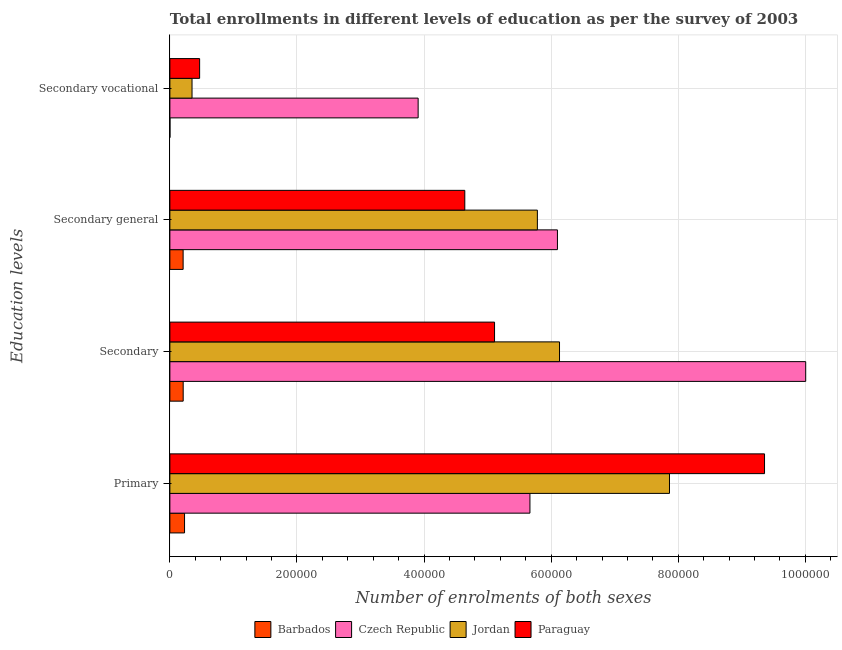Are the number of bars per tick equal to the number of legend labels?
Keep it short and to the point. Yes. Are the number of bars on each tick of the Y-axis equal?
Make the answer very short. Yes. How many bars are there on the 1st tick from the top?
Your answer should be very brief. 4. How many bars are there on the 4th tick from the bottom?
Keep it short and to the point. 4. What is the label of the 4th group of bars from the top?
Your answer should be very brief. Primary. What is the number of enrolments in secondary education in Czech Republic?
Offer a very short reply. 1.00e+06. Across all countries, what is the maximum number of enrolments in secondary education?
Make the answer very short. 1.00e+06. Across all countries, what is the minimum number of enrolments in secondary general education?
Ensure brevity in your answer.  2.08e+04. In which country was the number of enrolments in secondary vocational education maximum?
Offer a very short reply. Czech Republic. In which country was the number of enrolments in secondary vocational education minimum?
Ensure brevity in your answer.  Barbados. What is the total number of enrolments in primary education in the graph?
Provide a succinct answer. 2.31e+06. What is the difference between the number of enrolments in secondary vocational education in Czech Republic and that in Jordan?
Your answer should be compact. 3.56e+05. What is the difference between the number of enrolments in secondary vocational education in Czech Republic and the number of enrolments in primary education in Barbados?
Offer a terse response. 3.68e+05. What is the average number of enrolments in primary education per country?
Offer a terse response. 5.78e+05. What is the difference between the number of enrolments in secondary vocational education and number of enrolments in secondary general education in Jordan?
Offer a very short reply. -5.43e+05. In how many countries, is the number of enrolments in secondary general education greater than 1000000 ?
Ensure brevity in your answer.  0. What is the ratio of the number of enrolments in secondary vocational education in Paraguay to that in Jordan?
Provide a succinct answer. 1.34. Is the number of enrolments in secondary education in Czech Republic less than that in Paraguay?
Offer a very short reply. No. What is the difference between the highest and the second highest number of enrolments in primary education?
Offer a very short reply. 1.50e+05. What is the difference between the highest and the lowest number of enrolments in primary education?
Your answer should be very brief. 9.13e+05. Is the sum of the number of enrolments in secondary vocational education in Czech Republic and Jordan greater than the maximum number of enrolments in primary education across all countries?
Ensure brevity in your answer.  No. What does the 1st bar from the top in Secondary represents?
Provide a short and direct response. Paraguay. What does the 3rd bar from the bottom in Primary represents?
Provide a succinct answer. Jordan. Is it the case that in every country, the sum of the number of enrolments in primary education and number of enrolments in secondary education is greater than the number of enrolments in secondary general education?
Give a very brief answer. Yes. Are all the bars in the graph horizontal?
Make the answer very short. Yes. What is the difference between two consecutive major ticks on the X-axis?
Offer a terse response. 2.00e+05. How are the legend labels stacked?
Give a very brief answer. Horizontal. What is the title of the graph?
Provide a succinct answer. Total enrollments in different levels of education as per the survey of 2003. Does "Uruguay" appear as one of the legend labels in the graph?
Offer a terse response. No. What is the label or title of the X-axis?
Offer a very short reply. Number of enrolments of both sexes. What is the label or title of the Y-axis?
Your answer should be compact. Education levels. What is the Number of enrolments of both sexes of Barbados in Primary?
Offer a very short reply. 2.31e+04. What is the Number of enrolments of both sexes in Czech Republic in Primary?
Offer a terse response. 5.67e+05. What is the Number of enrolments of both sexes of Jordan in Primary?
Ensure brevity in your answer.  7.86e+05. What is the Number of enrolments of both sexes in Paraguay in Primary?
Your answer should be compact. 9.36e+05. What is the Number of enrolments of both sexes in Barbados in Secondary?
Your answer should be compact. 2.09e+04. What is the Number of enrolments of both sexes in Czech Republic in Secondary?
Your answer should be very brief. 1.00e+06. What is the Number of enrolments of both sexes of Jordan in Secondary?
Offer a very short reply. 6.13e+05. What is the Number of enrolments of both sexes in Paraguay in Secondary?
Ensure brevity in your answer.  5.11e+05. What is the Number of enrolments of both sexes in Barbados in Secondary general?
Provide a succinct answer. 2.08e+04. What is the Number of enrolments of both sexes of Czech Republic in Secondary general?
Make the answer very short. 6.10e+05. What is the Number of enrolments of both sexes of Jordan in Secondary general?
Give a very brief answer. 5.78e+05. What is the Number of enrolments of both sexes of Paraguay in Secondary general?
Ensure brevity in your answer.  4.64e+05. What is the Number of enrolments of both sexes in Barbados in Secondary vocational?
Keep it short and to the point. 109. What is the Number of enrolments of both sexes of Czech Republic in Secondary vocational?
Offer a very short reply. 3.91e+05. What is the Number of enrolments of both sexes in Jordan in Secondary vocational?
Ensure brevity in your answer.  3.49e+04. What is the Number of enrolments of both sexes of Paraguay in Secondary vocational?
Provide a succinct answer. 4.68e+04. Across all Education levels, what is the maximum Number of enrolments of both sexes of Barbados?
Provide a succinct answer. 2.31e+04. Across all Education levels, what is the maximum Number of enrolments of both sexes of Czech Republic?
Your answer should be very brief. 1.00e+06. Across all Education levels, what is the maximum Number of enrolments of both sexes of Jordan?
Ensure brevity in your answer.  7.86e+05. Across all Education levels, what is the maximum Number of enrolments of both sexes in Paraguay?
Keep it short and to the point. 9.36e+05. Across all Education levels, what is the minimum Number of enrolments of both sexes of Barbados?
Your answer should be compact. 109. Across all Education levels, what is the minimum Number of enrolments of both sexes of Czech Republic?
Your response must be concise. 3.91e+05. Across all Education levels, what is the minimum Number of enrolments of both sexes of Jordan?
Give a very brief answer. 3.49e+04. Across all Education levels, what is the minimum Number of enrolments of both sexes of Paraguay?
Offer a terse response. 4.68e+04. What is the total Number of enrolments of both sexes of Barbados in the graph?
Provide a succinct answer. 6.50e+04. What is the total Number of enrolments of both sexes in Czech Republic in the graph?
Offer a terse response. 2.57e+06. What is the total Number of enrolments of both sexes of Jordan in the graph?
Provide a short and direct response. 2.01e+06. What is the total Number of enrolments of both sexes in Paraguay in the graph?
Make the answer very short. 1.96e+06. What is the difference between the Number of enrolments of both sexes of Barbados in Primary and that in Secondary?
Offer a terse response. 2127. What is the difference between the Number of enrolments of both sexes of Czech Republic in Primary and that in Secondary?
Keep it short and to the point. -4.34e+05. What is the difference between the Number of enrolments of both sexes of Jordan in Primary and that in Secondary?
Offer a terse response. 1.73e+05. What is the difference between the Number of enrolments of both sexes of Paraguay in Primary and that in Secondary?
Your answer should be very brief. 4.25e+05. What is the difference between the Number of enrolments of both sexes of Barbados in Primary and that in Secondary general?
Keep it short and to the point. 2236. What is the difference between the Number of enrolments of both sexes of Czech Republic in Primary and that in Secondary general?
Give a very brief answer. -4.33e+04. What is the difference between the Number of enrolments of both sexes in Jordan in Primary and that in Secondary general?
Give a very brief answer. 2.08e+05. What is the difference between the Number of enrolments of both sexes of Paraguay in Primary and that in Secondary general?
Your answer should be compact. 4.72e+05. What is the difference between the Number of enrolments of both sexes in Barbados in Primary and that in Secondary vocational?
Ensure brevity in your answer.  2.30e+04. What is the difference between the Number of enrolments of both sexes in Czech Republic in Primary and that in Secondary vocational?
Offer a very short reply. 1.76e+05. What is the difference between the Number of enrolments of both sexes in Jordan in Primary and that in Secondary vocational?
Ensure brevity in your answer.  7.51e+05. What is the difference between the Number of enrolments of both sexes in Paraguay in Primary and that in Secondary vocational?
Give a very brief answer. 8.89e+05. What is the difference between the Number of enrolments of both sexes of Barbados in Secondary and that in Secondary general?
Offer a terse response. 109. What is the difference between the Number of enrolments of both sexes of Czech Republic in Secondary and that in Secondary general?
Offer a terse response. 3.91e+05. What is the difference between the Number of enrolments of both sexes of Jordan in Secondary and that in Secondary general?
Provide a short and direct response. 3.49e+04. What is the difference between the Number of enrolments of both sexes in Paraguay in Secondary and that in Secondary general?
Ensure brevity in your answer.  4.68e+04. What is the difference between the Number of enrolments of both sexes of Barbados in Secondary and that in Secondary vocational?
Ensure brevity in your answer.  2.08e+04. What is the difference between the Number of enrolments of both sexes in Czech Republic in Secondary and that in Secondary vocational?
Give a very brief answer. 6.10e+05. What is the difference between the Number of enrolments of both sexes of Jordan in Secondary and that in Secondary vocational?
Your response must be concise. 5.78e+05. What is the difference between the Number of enrolments of both sexes of Paraguay in Secondary and that in Secondary vocational?
Give a very brief answer. 4.64e+05. What is the difference between the Number of enrolments of both sexes of Barbados in Secondary general and that in Secondary vocational?
Offer a very short reply. 2.07e+04. What is the difference between the Number of enrolments of both sexes of Czech Republic in Secondary general and that in Secondary vocational?
Make the answer very short. 2.19e+05. What is the difference between the Number of enrolments of both sexes of Jordan in Secondary general and that in Secondary vocational?
Your response must be concise. 5.43e+05. What is the difference between the Number of enrolments of both sexes of Paraguay in Secondary general and that in Secondary vocational?
Offer a very short reply. 4.17e+05. What is the difference between the Number of enrolments of both sexes in Barbados in Primary and the Number of enrolments of both sexes in Czech Republic in Secondary?
Ensure brevity in your answer.  -9.77e+05. What is the difference between the Number of enrolments of both sexes in Barbados in Primary and the Number of enrolments of both sexes in Jordan in Secondary?
Ensure brevity in your answer.  -5.90e+05. What is the difference between the Number of enrolments of both sexes in Barbados in Primary and the Number of enrolments of both sexes in Paraguay in Secondary?
Your response must be concise. -4.88e+05. What is the difference between the Number of enrolments of both sexes of Czech Republic in Primary and the Number of enrolments of both sexes of Jordan in Secondary?
Your answer should be compact. -4.65e+04. What is the difference between the Number of enrolments of both sexes in Czech Republic in Primary and the Number of enrolments of both sexes in Paraguay in Secondary?
Ensure brevity in your answer.  5.57e+04. What is the difference between the Number of enrolments of both sexes in Jordan in Primary and the Number of enrolments of both sexes in Paraguay in Secondary?
Ensure brevity in your answer.  2.75e+05. What is the difference between the Number of enrolments of both sexes of Barbados in Primary and the Number of enrolments of both sexes of Czech Republic in Secondary general?
Your response must be concise. -5.87e+05. What is the difference between the Number of enrolments of both sexes of Barbados in Primary and the Number of enrolments of both sexes of Jordan in Secondary general?
Provide a succinct answer. -5.55e+05. What is the difference between the Number of enrolments of both sexes of Barbados in Primary and the Number of enrolments of both sexes of Paraguay in Secondary general?
Provide a succinct answer. -4.41e+05. What is the difference between the Number of enrolments of both sexes of Czech Republic in Primary and the Number of enrolments of both sexes of Jordan in Secondary general?
Make the answer very short. -1.17e+04. What is the difference between the Number of enrolments of both sexes in Czech Republic in Primary and the Number of enrolments of both sexes in Paraguay in Secondary general?
Keep it short and to the point. 1.03e+05. What is the difference between the Number of enrolments of both sexes of Jordan in Primary and the Number of enrolments of both sexes of Paraguay in Secondary general?
Make the answer very short. 3.22e+05. What is the difference between the Number of enrolments of both sexes in Barbados in Primary and the Number of enrolments of both sexes in Czech Republic in Secondary vocational?
Your answer should be very brief. -3.68e+05. What is the difference between the Number of enrolments of both sexes of Barbados in Primary and the Number of enrolments of both sexes of Jordan in Secondary vocational?
Offer a very short reply. -1.18e+04. What is the difference between the Number of enrolments of both sexes in Barbados in Primary and the Number of enrolments of both sexes in Paraguay in Secondary vocational?
Your answer should be very brief. -2.37e+04. What is the difference between the Number of enrolments of both sexes of Czech Republic in Primary and the Number of enrolments of both sexes of Jordan in Secondary vocational?
Give a very brief answer. 5.32e+05. What is the difference between the Number of enrolments of both sexes of Czech Republic in Primary and the Number of enrolments of both sexes of Paraguay in Secondary vocational?
Provide a short and direct response. 5.20e+05. What is the difference between the Number of enrolments of both sexes in Jordan in Primary and the Number of enrolments of both sexes in Paraguay in Secondary vocational?
Make the answer very short. 7.39e+05. What is the difference between the Number of enrolments of both sexes of Barbados in Secondary and the Number of enrolments of both sexes of Czech Republic in Secondary general?
Provide a short and direct response. -5.89e+05. What is the difference between the Number of enrolments of both sexes in Barbados in Secondary and the Number of enrolments of both sexes in Jordan in Secondary general?
Offer a very short reply. -5.57e+05. What is the difference between the Number of enrolments of both sexes in Barbados in Secondary and the Number of enrolments of both sexes in Paraguay in Secondary general?
Offer a terse response. -4.43e+05. What is the difference between the Number of enrolments of both sexes of Czech Republic in Secondary and the Number of enrolments of both sexes of Jordan in Secondary general?
Ensure brevity in your answer.  4.22e+05. What is the difference between the Number of enrolments of both sexes in Czech Republic in Secondary and the Number of enrolments of both sexes in Paraguay in Secondary general?
Keep it short and to the point. 5.36e+05. What is the difference between the Number of enrolments of both sexes of Jordan in Secondary and the Number of enrolments of both sexes of Paraguay in Secondary general?
Make the answer very short. 1.49e+05. What is the difference between the Number of enrolments of both sexes of Barbados in Secondary and the Number of enrolments of both sexes of Czech Republic in Secondary vocational?
Your response must be concise. -3.70e+05. What is the difference between the Number of enrolments of both sexes in Barbados in Secondary and the Number of enrolments of both sexes in Jordan in Secondary vocational?
Your response must be concise. -1.39e+04. What is the difference between the Number of enrolments of both sexes of Barbados in Secondary and the Number of enrolments of both sexes of Paraguay in Secondary vocational?
Offer a very short reply. -2.59e+04. What is the difference between the Number of enrolments of both sexes in Czech Republic in Secondary and the Number of enrolments of both sexes in Jordan in Secondary vocational?
Provide a short and direct response. 9.66e+05. What is the difference between the Number of enrolments of both sexes in Czech Republic in Secondary and the Number of enrolments of both sexes in Paraguay in Secondary vocational?
Your answer should be compact. 9.54e+05. What is the difference between the Number of enrolments of both sexes in Jordan in Secondary and the Number of enrolments of both sexes in Paraguay in Secondary vocational?
Offer a terse response. 5.66e+05. What is the difference between the Number of enrolments of both sexes in Barbados in Secondary general and the Number of enrolments of both sexes in Czech Republic in Secondary vocational?
Ensure brevity in your answer.  -3.70e+05. What is the difference between the Number of enrolments of both sexes of Barbados in Secondary general and the Number of enrolments of both sexes of Jordan in Secondary vocational?
Offer a terse response. -1.40e+04. What is the difference between the Number of enrolments of both sexes of Barbados in Secondary general and the Number of enrolments of both sexes of Paraguay in Secondary vocational?
Provide a short and direct response. -2.60e+04. What is the difference between the Number of enrolments of both sexes of Czech Republic in Secondary general and the Number of enrolments of both sexes of Jordan in Secondary vocational?
Make the answer very short. 5.75e+05. What is the difference between the Number of enrolments of both sexes in Czech Republic in Secondary general and the Number of enrolments of both sexes in Paraguay in Secondary vocational?
Your answer should be very brief. 5.63e+05. What is the difference between the Number of enrolments of both sexes in Jordan in Secondary general and the Number of enrolments of both sexes in Paraguay in Secondary vocational?
Make the answer very short. 5.31e+05. What is the average Number of enrolments of both sexes of Barbados per Education levels?
Ensure brevity in your answer.  1.62e+04. What is the average Number of enrolments of both sexes in Czech Republic per Education levels?
Your response must be concise. 6.42e+05. What is the average Number of enrolments of both sexes in Jordan per Education levels?
Your answer should be compact. 5.03e+05. What is the average Number of enrolments of both sexes in Paraguay per Education levels?
Offer a very short reply. 4.89e+05. What is the difference between the Number of enrolments of both sexes in Barbados and Number of enrolments of both sexes in Czech Republic in Primary?
Your answer should be compact. -5.44e+05. What is the difference between the Number of enrolments of both sexes in Barbados and Number of enrolments of both sexes in Jordan in Primary?
Provide a succinct answer. -7.63e+05. What is the difference between the Number of enrolments of both sexes in Barbados and Number of enrolments of both sexes in Paraguay in Primary?
Provide a succinct answer. -9.13e+05. What is the difference between the Number of enrolments of both sexes in Czech Republic and Number of enrolments of both sexes in Jordan in Primary?
Give a very brief answer. -2.20e+05. What is the difference between the Number of enrolments of both sexes of Czech Republic and Number of enrolments of both sexes of Paraguay in Primary?
Ensure brevity in your answer.  -3.69e+05. What is the difference between the Number of enrolments of both sexes in Jordan and Number of enrolments of both sexes in Paraguay in Primary?
Make the answer very short. -1.50e+05. What is the difference between the Number of enrolments of both sexes of Barbados and Number of enrolments of both sexes of Czech Republic in Secondary?
Offer a very short reply. -9.80e+05. What is the difference between the Number of enrolments of both sexes in Barbados and Number of enrolments of both sexes in Jordan in Secondary?
Keep it short and to the point. -5.92e+05. What is the difference between the Number of enrolments of both sexes of Barbados and Number of enrolments of both sexes of Paraguay in Secondary?
Provide a short and direct response. -4.90e+05. What is the difference between the Number of enrolments of both sexes of Czech Republic and Number of enrolments of both sexes of Jordan in Secondary?
Your answer should be very brief. 3.87e+05. What is the difference between the Number of enrolments of both sexes of Czech Republic and Number of enrolments of both sexes of Paraguay in Secondary?
Keep it short and to the point. 4.90e+05. What is the difference between the Number of enrolments of both sexes of Jordan and Number of enrolments of both sexes of Paraguay in Secondary?
Offer a very short reply. 1.02e+05. What is the difference between the Number of enrolments of both sexes of Barbados and Number of enrolments of both sexes of Czech Republic in Secondary general?
Your answer should be very brief. -5.89e+05. What is the difference between the Number of enrolments of both sexes of Barbados and Number of enrolments of both sexes of Jordan in Secondary general?
Your answer should be very brief. -5.57e+05. What is the difference between the Number of enrolments of both sexes of Barbados and Number of enrolments of both sexes of Paraguay in Secondary general?
Offer a very short reply. -4.43e+05. What is the difference between the Number of enrolments of both sexes in Czech Republic and Number of enrolments of both sexes in Jordan in Secondary general?
Offer a terse response. 3.16e+04. What is the difference between the Number of enrolments of both sexes in Czech Republic and Number of enrolments of both sexes in Paraguay in Secondary general?
Your response must be concise. 1.46e+05. What is the difference between the Number of enrolments of both sexes of Jordan and Number of enrolments of both sexes of Paraguay in Secondary general?
Provide a short and direct response. 1.14e+05. What is the difference between the Number of enrolments of both sexes of Barbados and Number of enrolments of both sexes of Czech Republic in Secondary vocational?
Make the answer very short. -3.91e+05. What is the difference between the Number of enrolments of both sexes of Barbados and Number of enrolments of both sexes of Jordan in Secondary vocational?
Provide a short and direct response. -3.47e+04. What is the difference between the Number of enrolments of both sexes in Barbados and Number of enrolments of both sexes in Paraguay in Secondary vocational?
Your answer should be compact. -4.67e+04. What is the difference between the Number of enrolments of both sexes of Czech Republic and Number of enrolments of both sexes of Jordan in Secondary vocational?
Your answer should be compact. 3.56e+05. What is the difference between the Number of enrolments of both sexes of Czech Republic and Number of enrolments of both sexes of Paraguay in Secondary vocational?
Offer a terse response. 3.44e+05. What is the difference between the Number of enrolments of both sexes in Jordan and Number of enrolments of both sexes in Paraguay in Secondary vocational?
Give a very brief answer. -1.20e+04. What is the ratio of the Number of enrolments of both sexes in Barbados in Primary to that in Secondary?
Provide a short and direct response. 1.1. What is the ratio of the Number of enrolments of both sexes in Czech Republic in Primary to that in Secondary?
Your answer should be very brief. 0.57. What is the ratio of the Number of enrolments of both sexes of Jordan in Primary to that in Secondary?
Your response must be concise. 1.28. What is the ratio of the Number of enrolments of both sexes of Paraguay in Primary to that in Secondary?
Make the answer very short. 1.83. What is the ratio of the Number of enrolments of both sexes of Barbados in Primary to that in Secondary general?
Give a very brief answer. 1.11. What is the ratio of the Number of enrolments of both sexes in Czech Republic in Primary to that in Secondary general?
Keep it short and to the point. 0.93. What is the ratio of the Number of enrolments of both sexes of Jordan in Primary to that in Secondary general?
Ensure brevity in your answer.  1.36. What is the ratio of the Number of enrolments of both sexes of Paraguay in Primary to that in Secondary general?
Offer a very short reply. 2.02. What is the ratio of the Number of enrolments of both sexes of Barbados in Primary to that in Secondary vocational?
Keep it short and to the point. 211.69. What is the ratio of the Number of enrolments of both sexes of Czech Republic in Primary to that in Secondary vocational?
Your answer should be very brief. 1.45. What is the ratio of the Number of enrolments of both sexes of Jordan in Primary to that in Secondary vocational?
Ensure brevity in your answer.  22.55. What is the ratio of the Number of enrolments of both sexes in Paraguay in Primary to that in Secondary vocational?
Give a very brief answer. 19.99. What is the ratio of the Number of enrolments of both sexes in Czech Republic in Secondary to that in Secondary general?
Keep it short and to the point. 1.64. What is the ratio of the Number of enrolments of both sexes of Jordan in Secondary to that in Secondary general?
Ensure brevity in your answer.  1.06. What is the ratio of the Number of enrolments of both sexes of Paraguay in Secondary to that in Secondary general?
Your response must be concise. 1.1. What is the ratio of the Number of enrolments of both sexes of Barbados in Secondary to that in Secondary vocational?
Your answer should be compact. 192.17. What is the ratio of the Number of enrolments of both sexes of Czech Republic in Secondary to that in Secondary vocational?
Your answer should be compact. 2.56. What is the ratio of the Number of enrolments of both sexes in Jordan in Secondary to that in Secondary vocational?
Provide a short and direct response. 17.59. What is the ratio of the Number of enrolments of both sexes in Paraguay in Secondary to that in Secondary vocational?
Provide a short and direct response. 10.91. What is the ratio of the Number of enrolments of both sexes of Barbados in Secondary general to that in Secondary vocational?
Ensure brevity in your answer.  191.17. What is the ratio of the Number of enrolments of both sexes in Czech Republic in Secondary general to that in Secondary vocational?
Make the answer very short. 1.56. What is the ratio of the Number of enrolments of both sexes in Jordan in Secondary general to that in Secondary vocational?
Offer a very short reply. 16.59. What is the ratio of the Number of enrolments of both sexes in Paraguay in Secondary general to that in Secondary vocational?
Offer a very short reply. 9.91. What is the difference between the highest and the second highest Number of enrolments of both sexes in Barbados?
Make the answer very short. 2127. What is the difference between the highest and the second highest Number of enrolments of both sexes in Czech Republic?
Offer a terse response. 3.91e+05. What is the difference between the highest and the second highest Number of enrolments of both sexes in Jordan?
Offer a very short reply. 1.73e+05. What is the difference between the highest and the second highest Number of enrolments of both sexes in Paraguay?
Offer a terse response. 4.25e+05. What is the difference between the highest and the lowest Number of enrolments of both sexes in Barbados?
Your answer should be very brief. 2.30e+04. What is the difference between the highest and the lowest Number of enrolments of both sexes in Czech Republic?
Your answer should be compact. 6.10e+05. What is the difference between the highest and the lowest Number of enrolments of both sexes of Jordan?
Offer a terse response. 7.51e+05. What is the difference between the highest and the lowest Number of enrolments of both sexes in Paraguay?
Ensure brevity in your answer.  8.89e+05. 